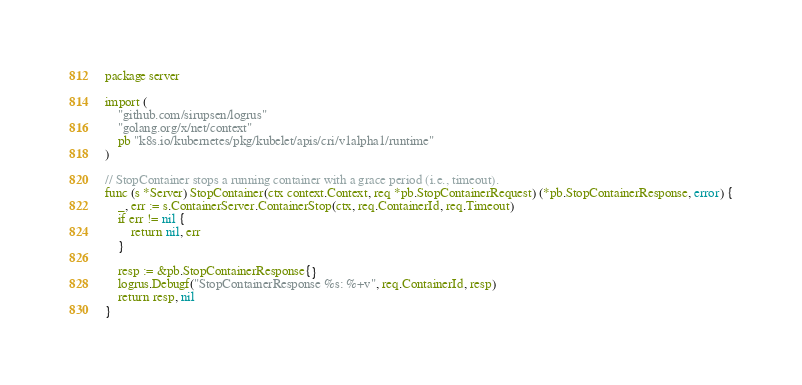Convert code to text. <code><loc_0><loc_0><loc_500><loc_500><_Go_>package server

import (
	"github.com/sirupsen/logrus"
	"golang.org/x/net/context"
	pb "k8s.io/kubernetes/pkg/kubelet/apis/cri/v1alpha1/runtime"
)

// StopContainer stops a running container with a grace period (i.e., timeout).
func (s *Server) StopContainer(ctx context.Context, req *pb.StopContainerRequest) (*pb.StopContainerResponse, error) {
	_, err := s.ContainerServer.ContainerStop(ctx, req.ContainerId, req.Timeout)
	if err != nil {
		return nil, err
	}

	resp := &pb.StopContainerResponse{}
	logrus.Debugf("StopContainerResponse %s: %+v", req.ContainerId, resp)
	return resp, nil
}
</code> 